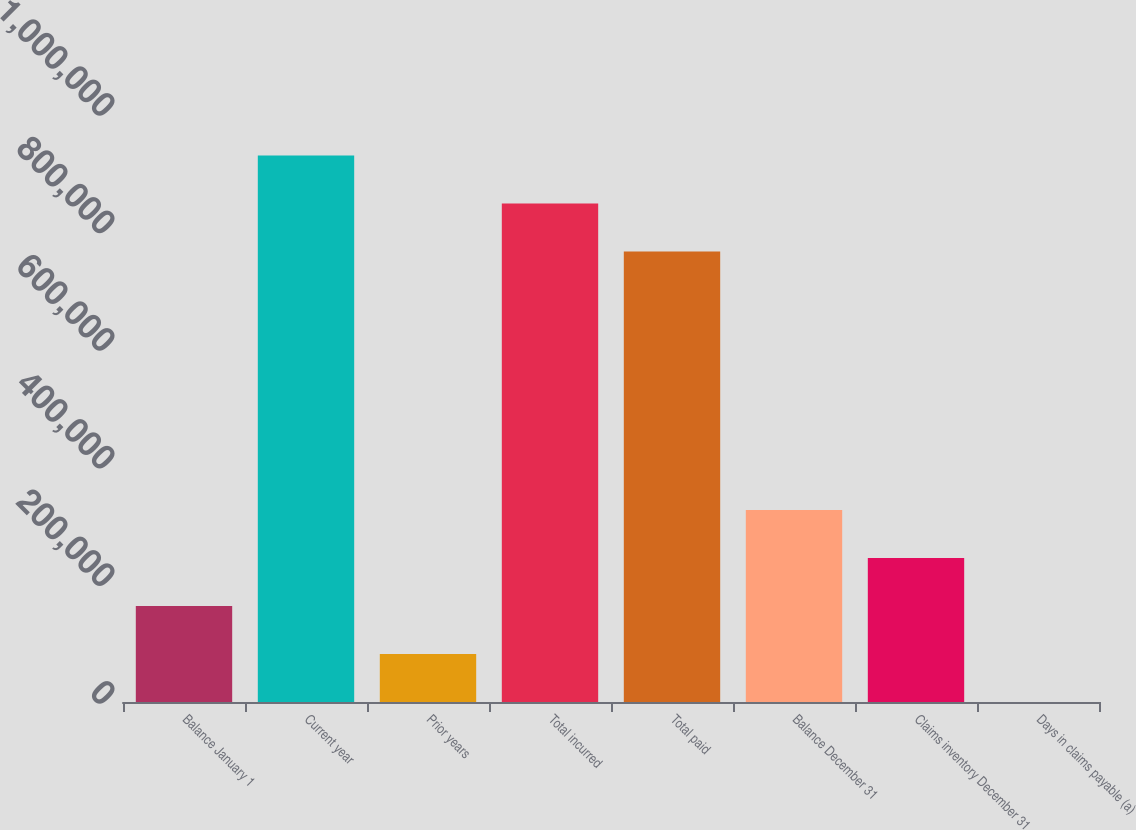Convert chart. <chart><loc_0><loc_0><loc_500><loc_500><bar_chart><fcel>Balance January 1<fcel>Current year<fcel>Prior years<fcel>Total incurred<fcel>Total paid<fcel>Balance December 31<fcel>Claims inventory December 31<fcel>Days in claims payable (a)<nl><fcel>163337<fcel>929244<fcel>81701.6<fcel>847609<fcel>765974<fcel>326607<fcel>244972<fcel>66.5<nl></chart> 